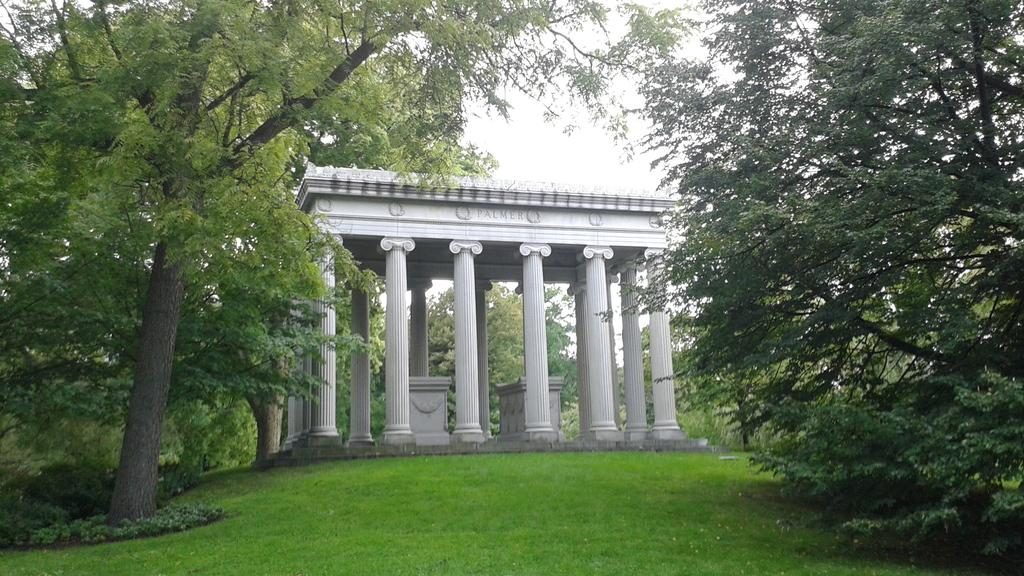What type of building is in the image? There is a white building in the image. What natural elements can be seen in the image? There are trees and grass in the image. What part of the natural environment is visible in the image? The sky is visible in the image. How many nails can be seen in the image? There are no nails present in the image. What type of glove is visible on the tree in the image? There is no glove present on the tree in the image. 